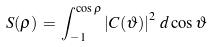<formula> <loc_0><loc_0><loc_500><loc_500>S ( \rho ) \, = \, \int _ { - 1 } ^ { \cos \rho } \left | C ( \vartheta ) \right | ^ { 2 } \, d \cos \vartheta</formula> 